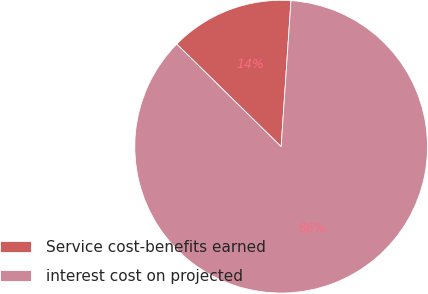<chart> <loc_0><loc_0><loc_500><loc_500><pie_chart><fcel>Service cost-benefits earned<fcel>interest cost on projected<nl><fcel>13.71%<fcel>86.29%<nl></chart> 